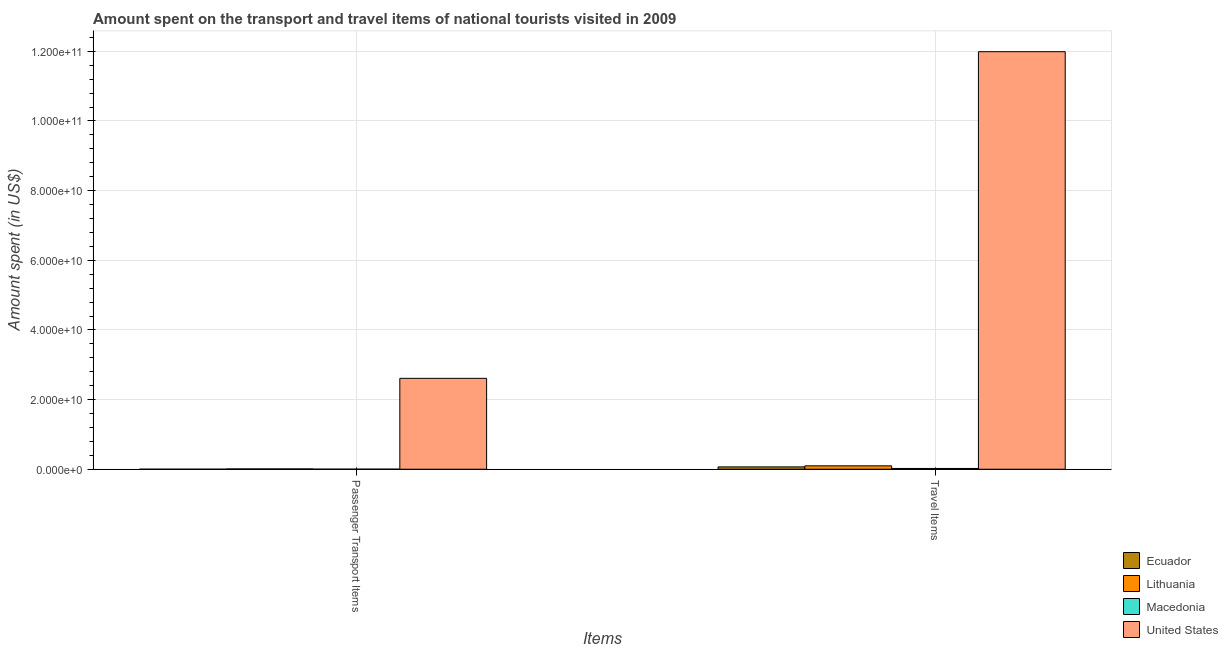Are the number of bars per tick equal to the number of legend labels?
Offer a terse response. Yes. How many bars are there on the 2nd tick from the left?
Provide a succinct answer. 4. What is the label of the 2nd group of bars from the left?
Provide a succinct answer. Travel Items. What is the amount spent on passenger transport items in Macedonia?
Your answer should be compact. 1.40e+07. Across all countries, what is the maximum amount spent on passenger transport items?
Your response must be concise. 2.61e+1. Across all countries, what is the minimum amount spent on passenger transport items?
Make the answer very short. 4.00e+06. In which country was the amount spent on passenger transport items maximum?
Offer a very short reply. United States. In which country was the amount spent in travel items minimum?
Give a very brief answer. Macedonia. What is the total amount spent in travel items in the graph?
Provide a short and direct response. 1.22e+11. What is the difference between the amount spent on passenger transport items in Macedonia and that in Lithuania?
Keep it short and to the point. -7.70e+07. What is the difference between the amount spent on passenger transport items in Macedonia and the amount spent in travel items in Lithuania?
Your answer should be compact. -9.58e+08. What is the average amount spent in travel items per country?
Make the answer very short. 3.04e+1. What is the difference between the amount spent in travel items and amount spent on passenger transport items in Lithuania?
Your answer should be compact. 8.81e+08. What is the ratio of the amount spent in travel items in Macedonia to that in Lithuania?
Keep it short and to the point. 0.22. Is the amount spent on passenger transport items in Macedonia less than that in Lithuania?
Give a very brief answer. Yes. In how many countries, is the amount spent in travel items greater than the average amount spent in travel items taken over all countries?
Ensure brevity in your answer.  1. What does the 2nd bar from the left in Travel Items represents?
Keep it short and to the point. Lithuania. Does the graph contain grids?
Keep it short and to the point. Yes. How are the legend labels stacked?
Your response must be concise. Vertical. What is the title of the graph?
Ensure brevity in your answer.  Amount spent on the transport and travel items of national tourists visited in 2009. What is the label or title of the X-axis?
Offer a terse response. Items. What is the label or title of the Y-axis?
Provide a succinct answer. Amount spent (in US$). What is the Amount spent (in US$) in Ecuador in Passenger Transport Items?
Ensure brevity in your answer.  4.00e+06. What is the Amount spent (in US$) in Lithuania in Passenger Transport Items?
Make the answer very short. 9.10e+07. What is the Amount spent (in US$) of Macedonia in Passenger Transport Items?
Give a very brief answer. 1.40e+07. What is the Amount spent (in US$) in United States in Passenger Transport Items?
Provide a succinct answer. 2.61e+1. What is the Amount spent (in US$) of Ecuador in Travel Items?
Make the answer very short. 6.70e+08. What is the Amount spent (in US$) in Lithuania in Travel Items?
Provide a short and direct response. 9.72e+08. What is the Amount spent (in US$) in Macedonia in Travel Items?
Offer a very short reply. 2.18e+08. What is the Amount spent (in US$) in United States in Travel Items?
Offer a terse response. 1.20e+11. Across all Items, what is the maximum Amount spent (in US$) in Ecuador?
Your answer should be compact. 6.70e+08. Across all Items, what is the maximum Amount spent (in US$) of Lithuania?
Provide a short and direct response. 9.72e+08. Across all Items, what is the maximum Amount spent (in US$) in Macedonia?
Your response must be concise. 2.18e+08. Across all Items, what is the maximum Amount spent (in US$) in United States?
Provide a succinct answer. 1.20e+11. Across all Items, what is the minimum Amount spent (in US$) in Ecuador?
Make the answer very short. 4.00e+06. Across all Items, what is the minimum Amount spent (in US$) of Lithuania?
Keep it short and to the point. 9.10e+07. Across all Items, what is the minimum Amount spent (in US$) in Macedonia?
Offer a terse response. 1.40e+07. Across all Items, what is the minimum Amount spent (in US$) in United States?
Provide a succinct answer. 2.61e+1. What is the total Amount spent (in US$) in Ecuador in the graph?
Offer a terse response. 6.74e+08. What is the total Amount spent (in US$) of Lithuania in the graph?
Your answer should be very brief. 1.06e+09. What is the total Amount spent (in US$) of Macedonia in the graph?
Make the answer very short. 2.32e+08. What is the total Amount spent (in US$) of United States in the graph?
Your response must be concise. 1.46e+11. What is the difference between the Amount spent (in US$) of Ecuador in Passenger Transport Items and that in Travel Items?
Offer a terse response. -6.66e+08. What is the difference between the Amount spent (in US$) in Lithuania in Passenger Transport Items and that in Travel Items?
Your answer should be compact. -8.81e+08. What is the difference between the Amount spent (in US$) of Macedonia in Passenger Transport Items and that in Travel Items?
Ensure brevity in your answer.  -2.04e+08. What is the difference between the Amount spent (in US$) in United States in Passenger Transport Items and that in Travel Items?
Offer a very short reply. -9.38e+1. What is the difference between the Amount spent (in US$) in Ecuador in Passenger Transport Items and the Amount spent (in US$) in Lithuania in Travel Items?
Your answer should be compact. -9.68e+08. What is the difference between the Amount spent (in US$) of Ecuador in Passenger Transport Items and the Amount spent (in US$) of Macedonia in Travel Items?
Offer a terse response. -2.14e+08. What is the difference between the Amount spent (in US$) of Ecuador in Passenger Transport Items and the Amount spent (in US$) of United States in Travel Items?
Keep it short and to the point. -1.20e+11. What is the difference between the Amount spent (in US$) of Lithuania in Passenger Transport Items and the Amount spent (in US$) of Macedonia in Travel Items?
Provide a succinct answer. -1.27e+08. What is the difference between the Amount spent (in US$) of Lithuania in Passenger Transport Items and the Amount spent (in US$) of United States in Travel Items?
Provide a short and direct response. -1.20e+11. What is the difference between the Amount spent (in US$) in Macedonia in Passenger Transport Items and the Amount spent (in US$) in United States in Travel Items?
Make the answer very short. -1.20e+11. What is the average Amount spent (in US$) in Ecuador per Items?
Your answer should be very brief. 3.37e+08. What is the average Amount spent (in US$) of Lithuania per Items?
Provide a short and direct response. 5.32e+08. What is the average Amount spent (in US$) of Macedonia per Items?
Ensure brevity in your answer.  1.16e+08. What is the average Amount spent (in US$) in United States per Items?
Offer a very short reply. 7.30e+1. What is the difference between the Amount spent (in US$) in Ecuador and Amount spent (in US$) in Lithuania in Passenger Transport Items?
Make the answer very short. -8.70e+07. What is the difference between the Amount spent (in US$) in Ecuador and Amount spent (in US$) in Macedonia in Passenger Transport Items?
Ensure brevity in your answer.  -1.00e+07. What is the difference between the Amount spent (in US$) in Ecuador and Amount spent (in US$) in United States in Passenger Transport Items?
Provide a succinct answer. -2.61e+1. What is the difference between the Amount spent (in US$) in Lithuania and Amount spent (in US$) in Macedonia in Passenger Transport Items?
Provide a short and direct response. 7.70e+07. What is the difference between the Amount spent (in US$) in Lithuania and Amount spent (in US$) in United States in Passenger Transport Items?
Provide a short and direct response. -2.60e+1. What is the difference between the Amount spent (in US$) in Macedonia and Amount spent (in US$) in United States in Passenger Transport Items?
Provide a succinct answer. -2.61e+1. What is the difference between the Amount spent (in US$) in Ecuador and Amount spent (in US$) in Lithuania in Travel Items?
Keep it short and to the point. -3.02e+08. What is the difference between the Amount spent (in US$) in Ecuador and Amount spent (in US$) in Macedonia in Travel Items?
Your answer should be compact. 4.52e+08. What is the difference between the Amount spent (in US$) of Ecuador and Amount spent (in US$) of United States in Travel Items?
Offer a terse response. -1.19e+11. What is the difference between the Amount spent (in US$) in Lithuania and Amount spent (in US$) in Macedonia in Travel Items?
Your answer should be very brief. 7.54e+08. What is the difference between the Amount spent (in US$) of Lithuania and Amount spent (in US$) of United States in Travel Items?
Give a very brief answer. -1.19e+11. What is the difference between the Amount spent (in US$) in Macedonia and Amount spent (in US$) in United States in Travel Items?
Your answer should be very brief. -1.20e+11. What is the ratio of the Amount spent (in US$) in Ecuador in Passenger Transport Items to that in Travel Items?
Keep it short and to the point. 0.01. What is the ratio of the Amount spent (in US$) in Lithuania in Passenger Transport Items to that in Travel Items?
Give a very brief answer. 0.09. What is the ratio of the Amount spent (in US$) in Macedonia in Passenger Transport Items to that in Travel Items?
Provide a short and direct response. 0.06. What is the ratio of the Amount spent (in US$) in United States in Passenger Transport Items to that in Travel Items?
Give a very brief answer. 0.22. What is the difference between the highest and the second highest Amount spent (in US$) of Ecuador?
Offer a terse response. 6.66e+08. What is the difference between the highest and the second highest Amount spent (in US$) of Lithuania?
Keep it short and to the point. 8.81e+08. What is the difference between the highest and the second highest Amount spent (in US$) in Macedonia?
Offer a very short reply. 2.04e+08. What is the difference between the highest and the second highest Amount spent (in US$) in United States?
Your answer should be very brief. 9.38e+1. What is the difference between the highest and the lowest Amount spent (in US$) in Ecuador?
Keep it short and to the point. 6.66e+08. What is the difference between the highest and the lowest Amount spent (in US$) of Lithuania?
Your answer should be compact. 8.81e+08. What is the difference between the highest and the lowest Amount spent (in US$) in Macedonia?
Your answer should be compact. 2.04e+08. What is the difference between the highest and the lowest Amount spent (in US$) of United States?
Keep it short and to the point. 9.38e+1. 